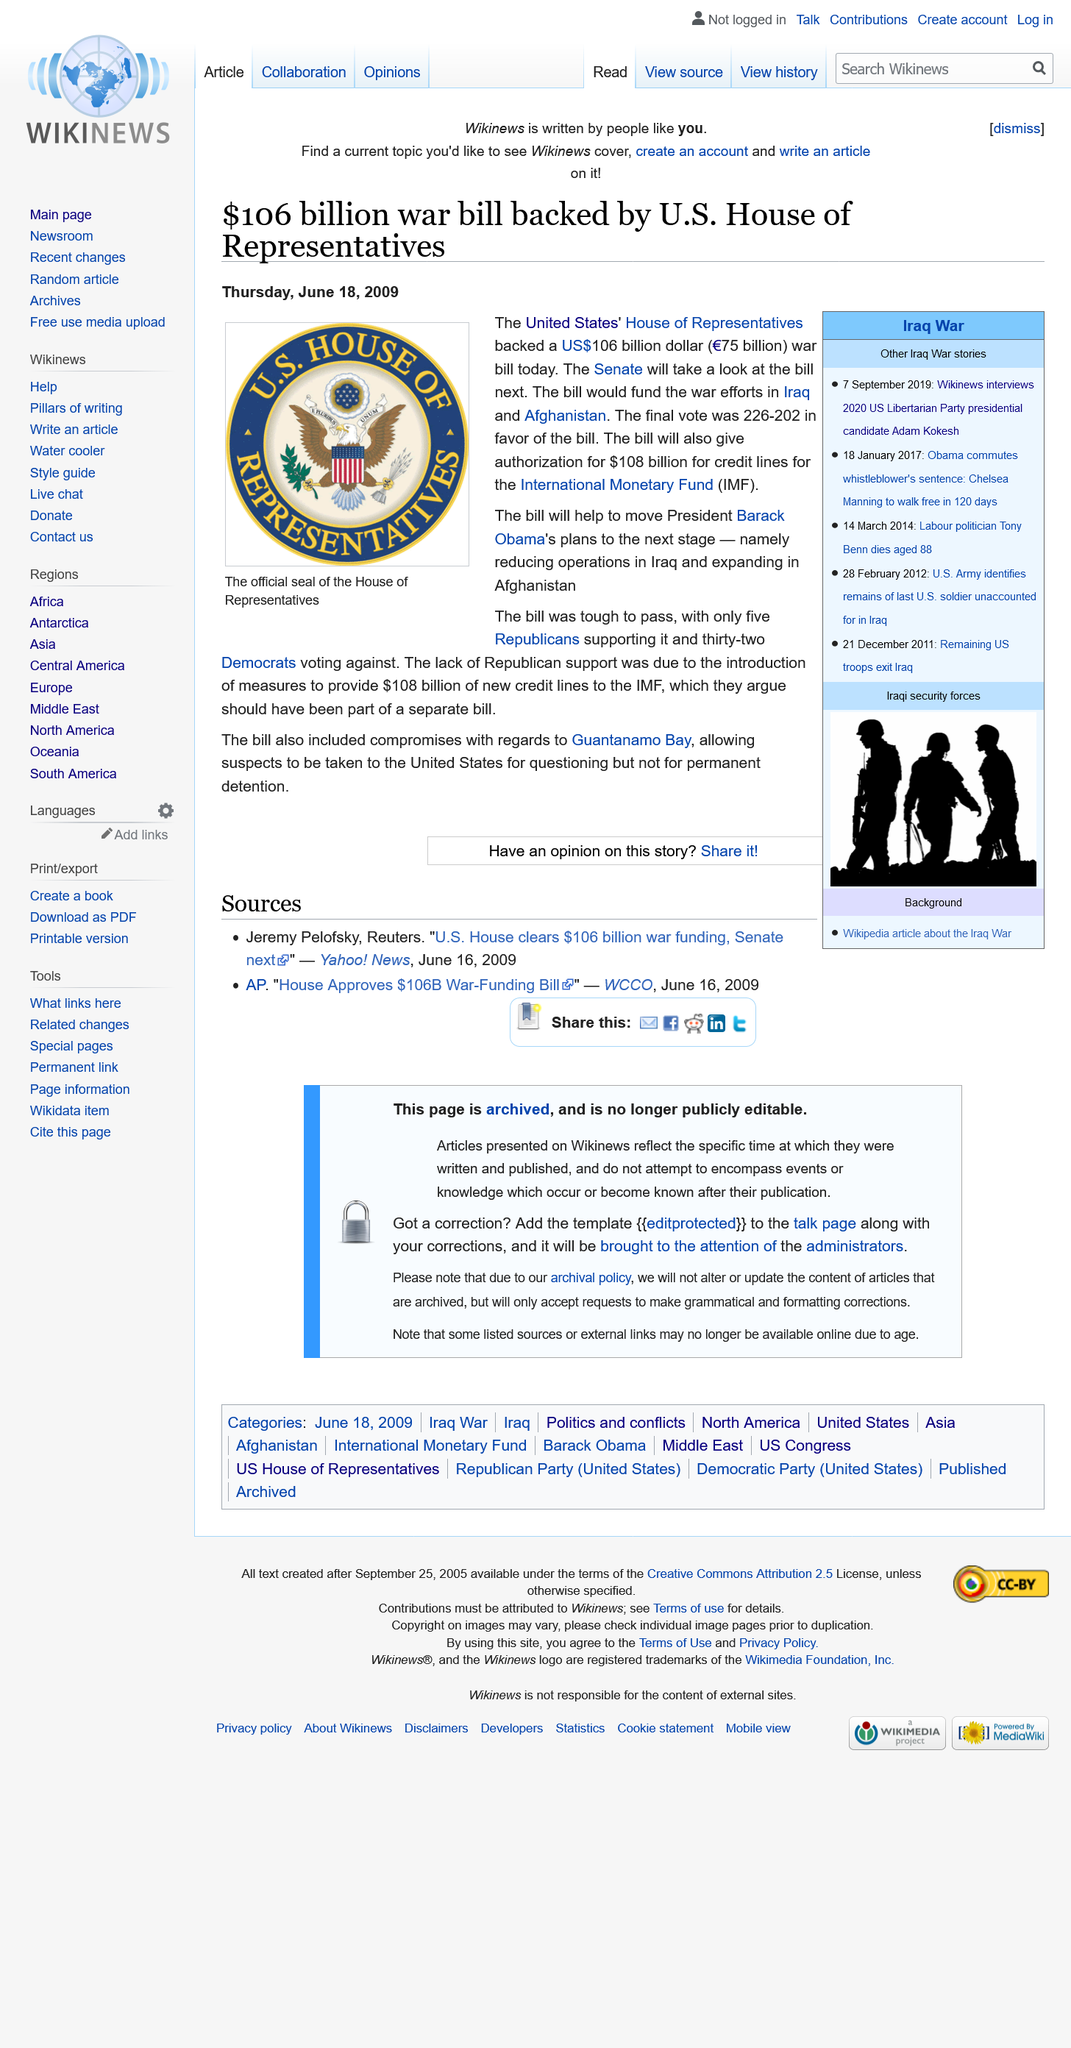Identify some key points in this picture. The International Monetary Fund, commonly known as the IMF, is an organization that provides financial assistance and advice to its member countries to help stabilize their economies and promote international monetary cooperation. The IMF was established in 1944 and is headquartered in Washington D.C. Its primary role is to promote international financial stability and facilitate the balanced growth of international trade. Five Republicans and thirty-two Democrats voted in support and opposition to the war bill, respectively. The bill is currently funding war efforts in Iraq and Afghanistan, and these efforts are being supported in various countries around the world. 